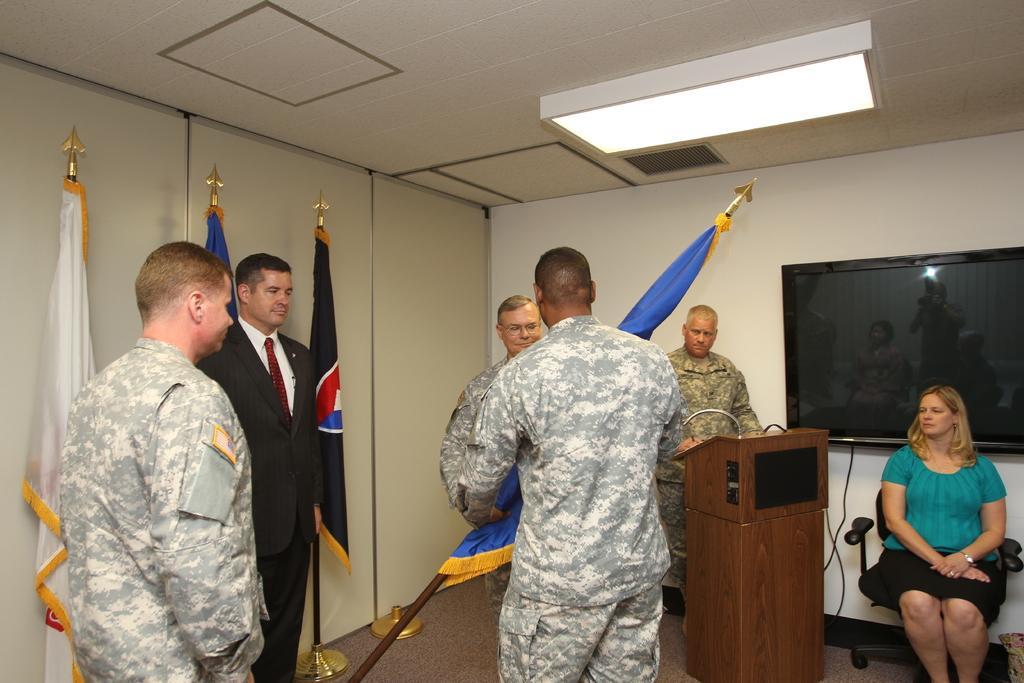Could you give a brief overview of what you see in this image? In this image I can see group of people standing. In front the person is wearing military uniform. Background I can see few flags in multi color and I can also see the screen attached to the wall and the wall is in white color. 